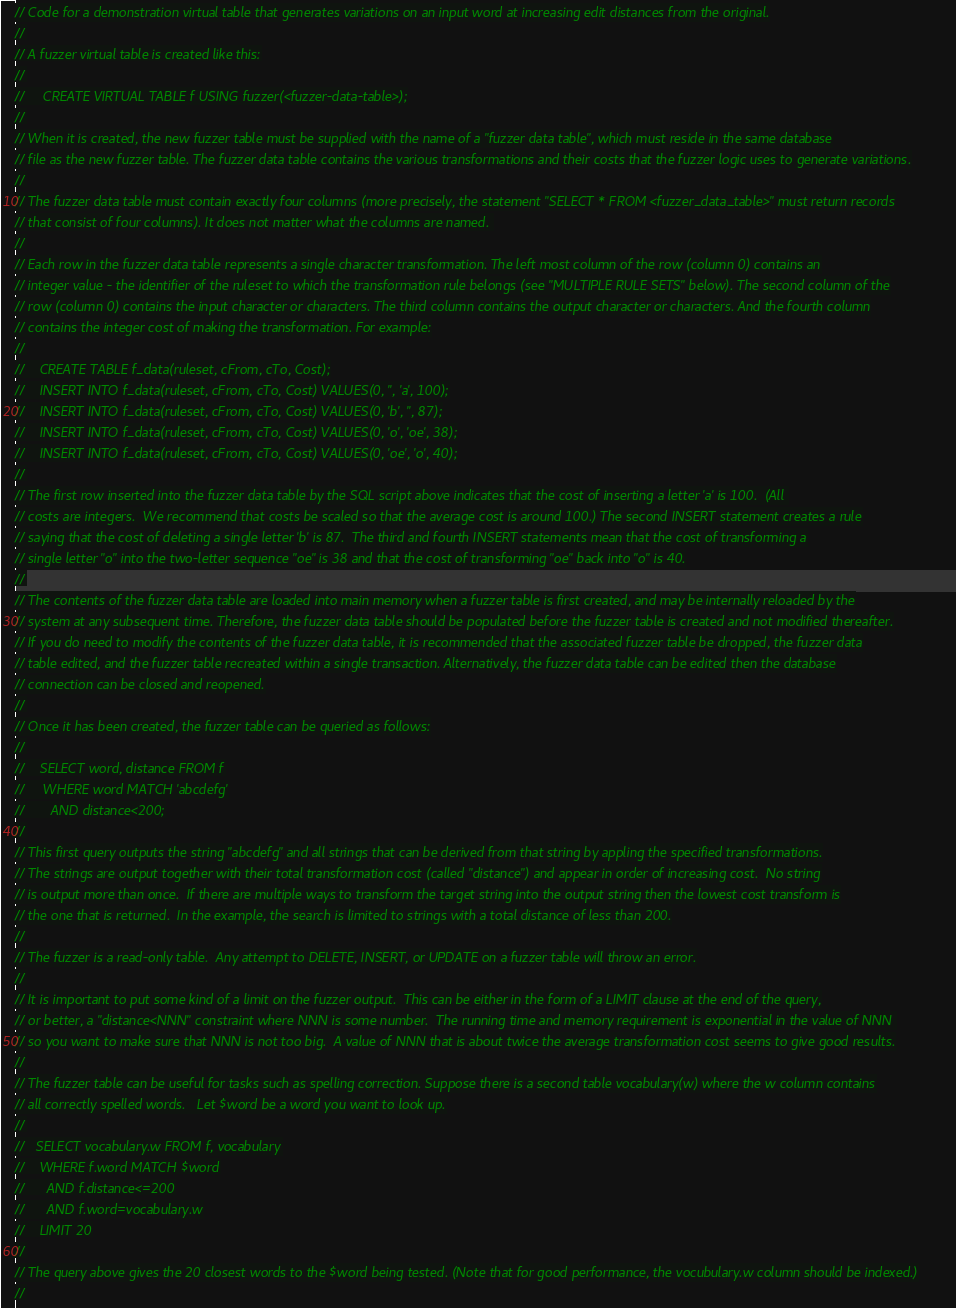Convert code to text. <code><loc_0><loc_0><loc_500><loc_500><_Cuda_>// Code for a demonstration virtual table that generates variations on an input word at increasing edit distances from the original.
//
// A fuzzer virtual table is created like this:
//
//     CREATE VIRTUAL TABLE f USING fuzzer(<fuzzer-data-table>);
//
// When it is created, the new fuzzer table must be supplied with the name of a "fuzzer data table", which must reside in the same database
// file as the new fuzzer table. The fuzzer data table contains the various transformations and their costs that the fuzzer logic uses to generate variations.
//
// The fuzzer data table must contain exactly four columns (more precisely, the statement "SELECT * FROM <fuzzer_data_table>" must return records
// that consist of four columns). It does not matter what the columns are named. 
//
// Each row in the fuzzer data table represents a single character transformation. The left most column of the row (column 0) contains an
// integer value - the identifier of the ruleset to which the transformation rule belongs (see "MULTIPLE RULE SETS" below). The second column of the
// row (column 0) contains the input character or characters. The third column contains the output character or characters. And the fourth column
// contains the integer cost of making the transformation. For example:
//
//    CREATE TABLE f_data(ruleset, cFrom, cTo, Cost);
//    INSERT INTO f_data(ruleset, cFrom, cTo, Cost) VALUES(0, '', 'a', 100);
//    INSERT INTO f_data(ruleset, cFrom, cTo, Cost) VALUES(0, 'b', '', 87);
//    INSERT INTO f_data(ruleset, cFrom, cTo, Cost) VALUES(0, 'o', 'oe', 38);
//    INSERT INTO f_data(ruleset, cFrom, cTo, Cost) VALUES(0, 'oe', 'o', 40);
//
// The first row inserted into the fuzzer data table by the SQL script above indicates that the cost of inserting a letter 'a' is 100.  (All 
// costs are integers.  We recommend that costs be scaled so that the average cost is around 100.) The second INSERT statement creates a rule
// saying that the cost of deleting a single letter 'b' is 87.  The third and fourth INSERT statements mean that the cost of transforming a
// single letter "o" into the two-letter sequence "oe" is 38 and that the cost of transforming "oe" back into "o" is 40.
//
// The contents of the fuzzer data table are loaded into main memory when a fuzzer table is first created, and may be internally reloaded by the
// system at any subsequent time. Therefore, the fuzzer data table should be populated before the fuzzer table is created and not modified thereafter.
// If you do need to modify the contents of the fuzzer data table, it is recommended that the associated fuzzer table be dropped, the fuzzer data
// table edited, and the fuzzer table recreated within a single transaction. Alternatively, the fuzzer data table can be edited then the database
// connection can be closed and reopened.
//
// Once it has been created, the fuzzer table can be queried as follows:
//
//    SELECT word, distance FROM f
//     WHERE word MATCH 'abcdefg'
//       AND distance<200;
//
// This first query outputs the string "abcdefg" and all strings that can be derived from that string by appling the specified transformations.
// The strings are output together with their total transformation cost (called "distance") and appear in order of increasing cost.  No string
// is output more than once.  If there are multiple ways to transform the target string into the output string then the lowest cost transform is
// the one that is returned.  In the example, the search is limited to strings with a total distance of less than 200.
//
// The fuzzer is a read-only table.  Any attempt to DELETE, INSERT, or UPDATE on a fuzzer table will throw an error.
//
// It is important to put some kind of a limit on the fuzzer output.  This can be either in the form of a LIMIT clause at the end of the query,
// or better, a "distance<NNN" constraint where NNN is some number.  The running time and memory requirement is exponential in the value of NNN 
// so you want to make sure that NNN is not too big.  A value of NNN that is about twice the average transformation cost seems to give good results.
//
// The fuzzer table can be useful for tasks such as spelling correction. Suppose there is a second table vocabulary(w) where the w column contains
// all correctly spelled words.   Let $word be a word you want to look up.
//
//   SELECT vocabulary.w FROM f, vocabulary
//    WHERE f.word MATCH $word
//      AND f.distance<=200
//      AND f.word=vocabulary.w
//    LIMIT 20
//
// The query above gives the 20 closest words to the $word being tested. (Note that for good performance, the vocubulary.w column should be indexed.)
//</code> 